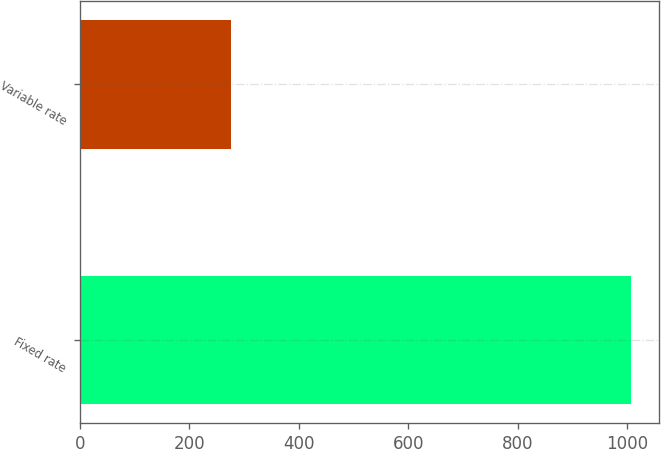Convert chart to OTSL. <chart><loc_0><loc_0><loc_500><loc_500><bar_chart><fcel>Fixed rate<fcel>Variable rate<nl><fcel>1007.8<fcel>275.3<nl></chart> 